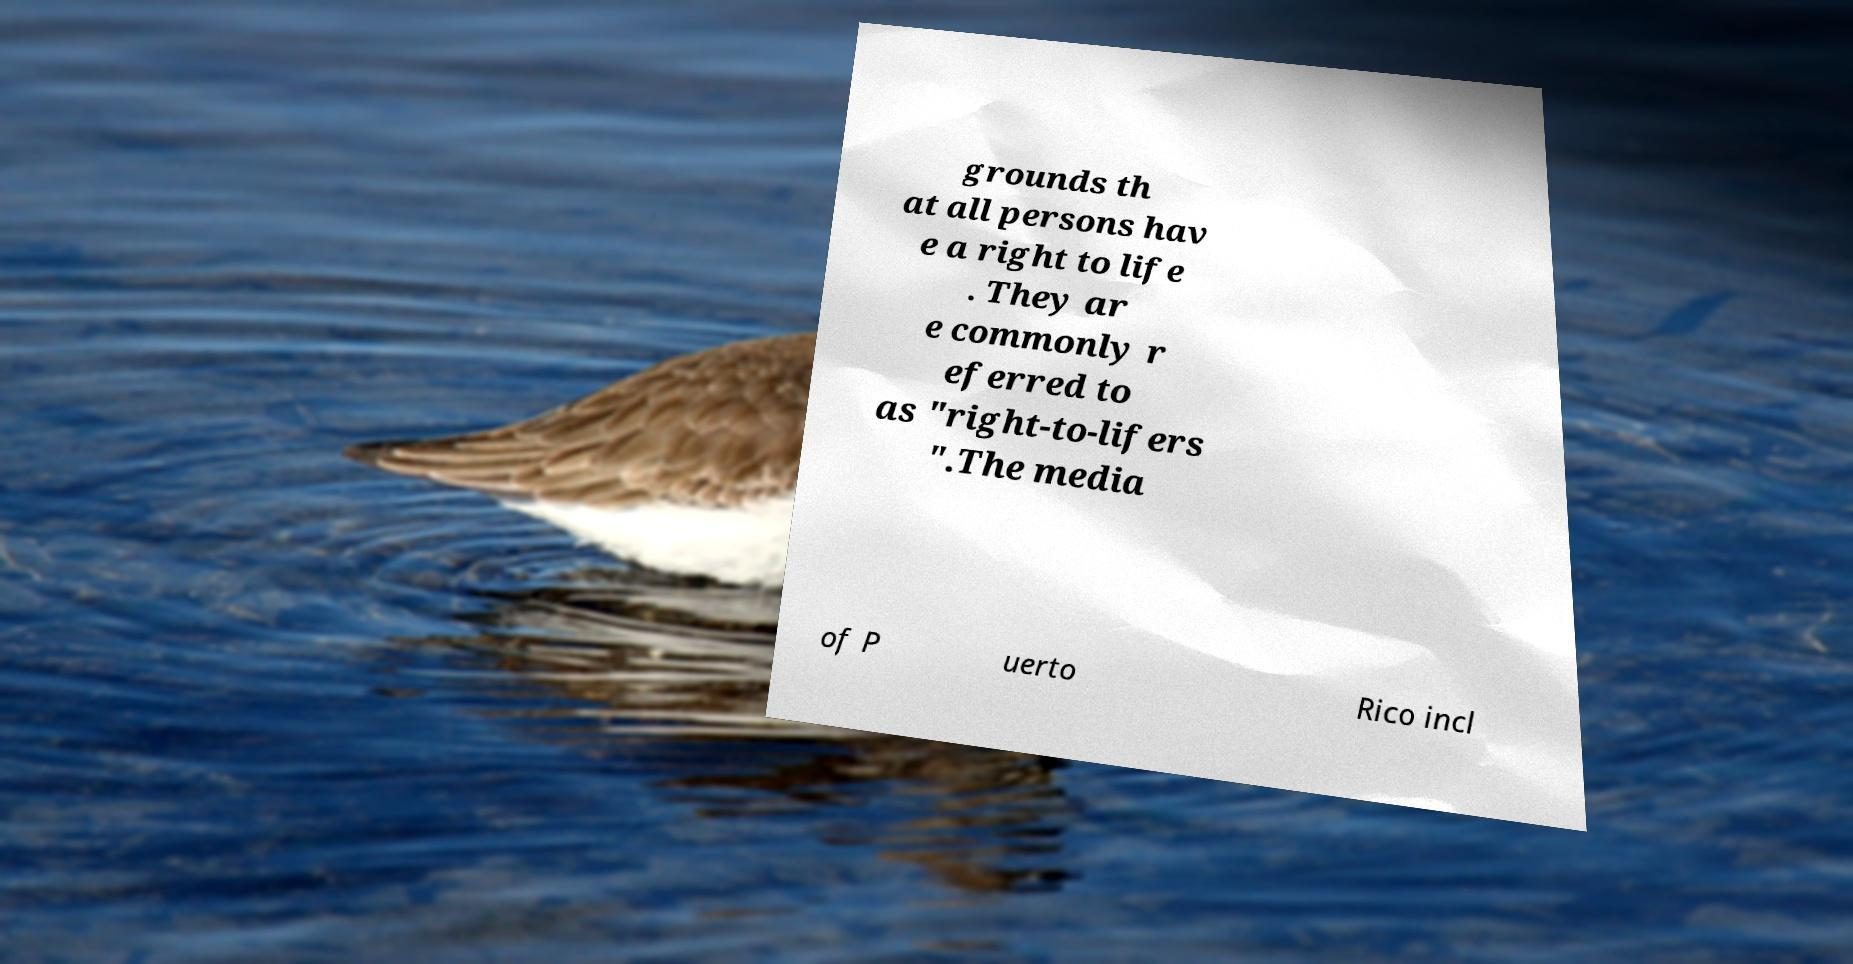I need the written content from this picture converted into text. Can you do that? grounds th at all persons hav e a right to life . They ar e commonly r eferred to as "right-to-lifers ".The media of P uerto Rico incl 